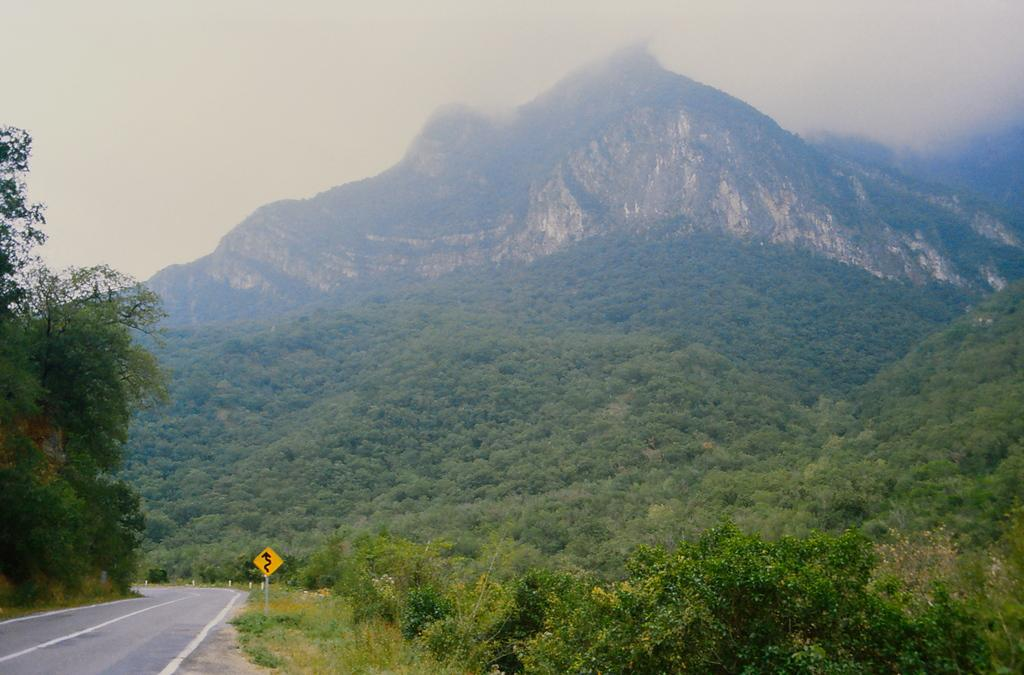What is present in the bottom left corner of the image? There is a sign board and a road in the bottom left corner of the image. What can be seen in the middle of the image? There are trees and a mountain in the middle of the image. What is visible in the background of the image? The sky is visible in the background of the image. What type of noise can be heard coming from the bed in the image? There is no bed present in the image, so it is not possible to determine what noise might be heard. 